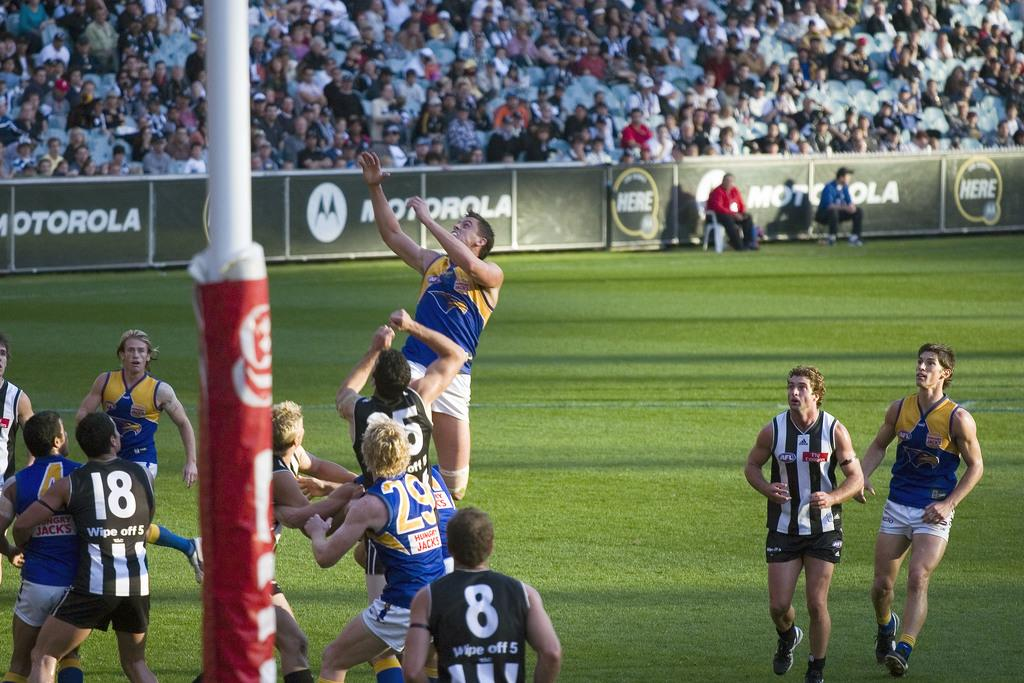<image>
Describe the image concisely. The blue team is sponsored by Hungry Jacks. 